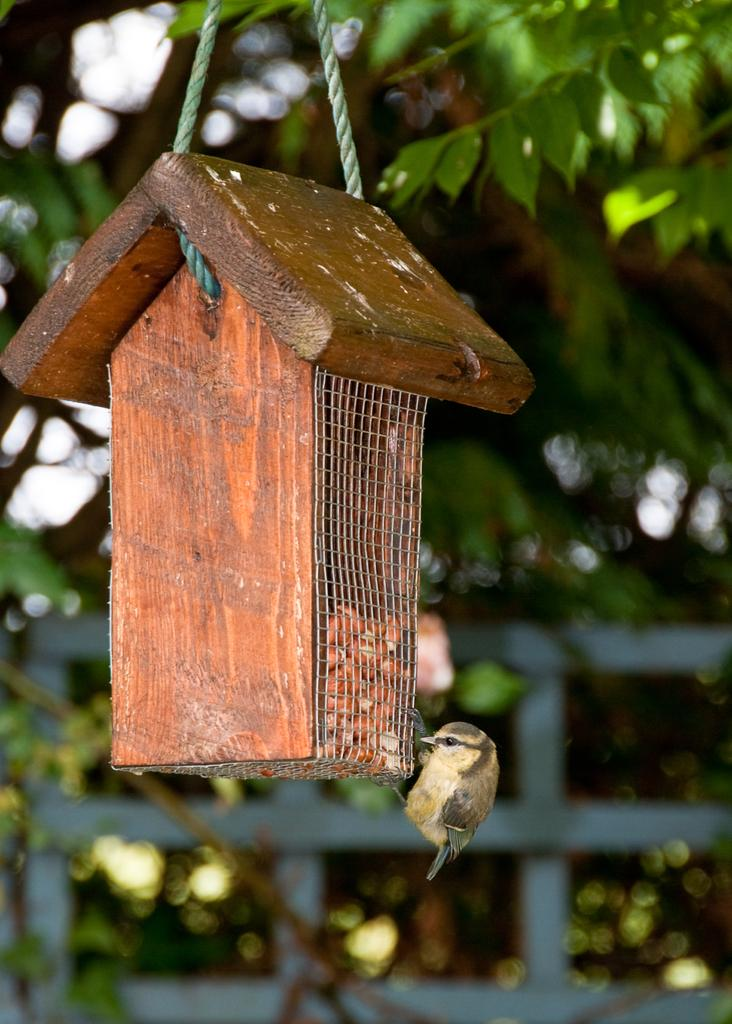What is on the birdhouse in the image? There is a bird on the birdhouse in the image. What can be seen in the background of the image? There is a metal fence and trees in the background of the image. How many brothers are present in the image? There are no brothers present in the image; it features a bird on a birdhouse with a metal fence and trees in the background. 